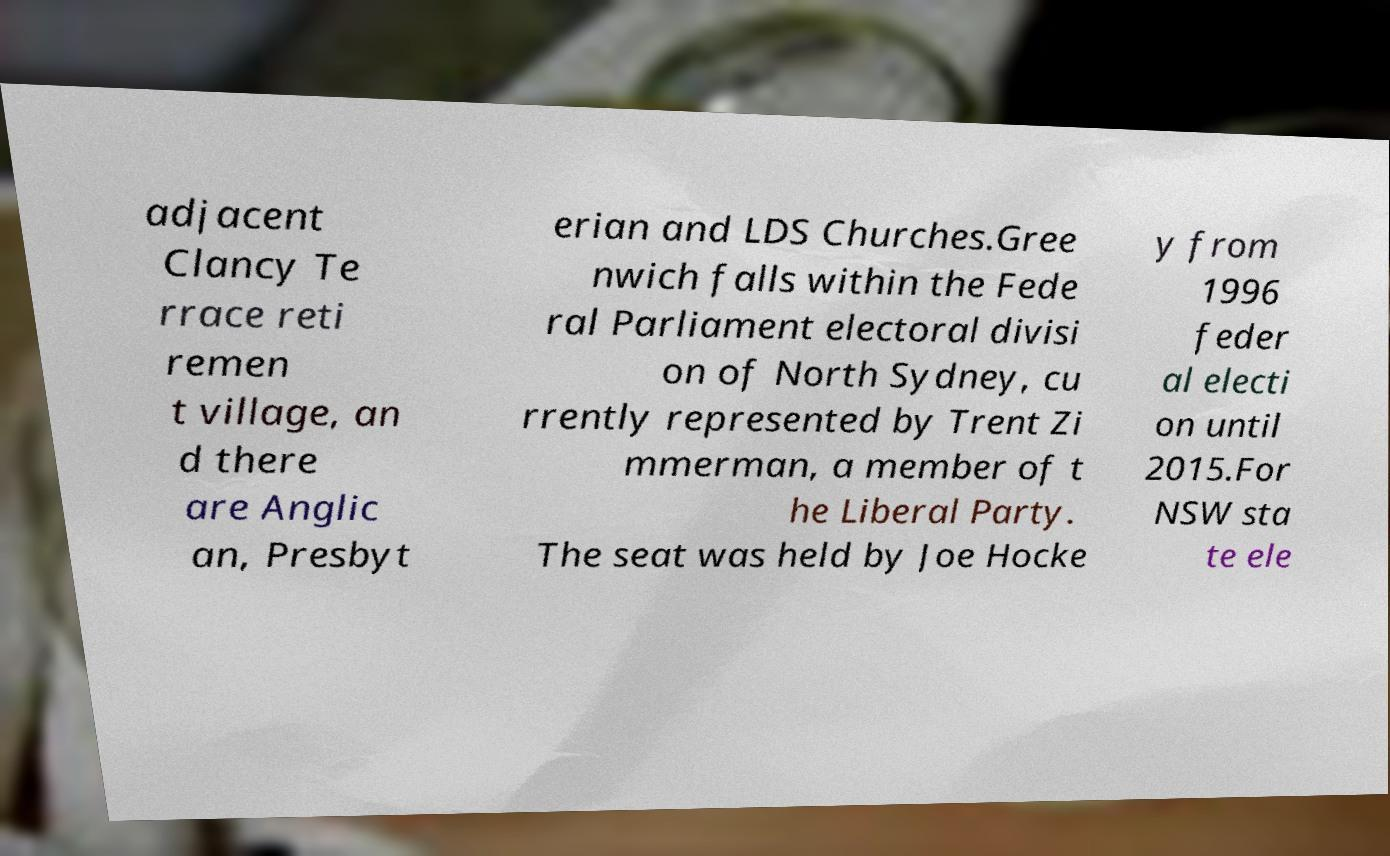I need the written content from this picture converted into text. Can you do that? adjacent Clancy Te rrace reti remen t village, an d there are Anglic an, Presbyt erian and LDS Churches.Gree nwich falls within the Fede ral Parliament electoral divisi on of North Sydney, cu rrently represented by Trent Zi mmerman, a member of t he Liberal Party. The seat was held by Joe Hocke y from 1996 feder al electi on until 2015.For NSW sta te ele 